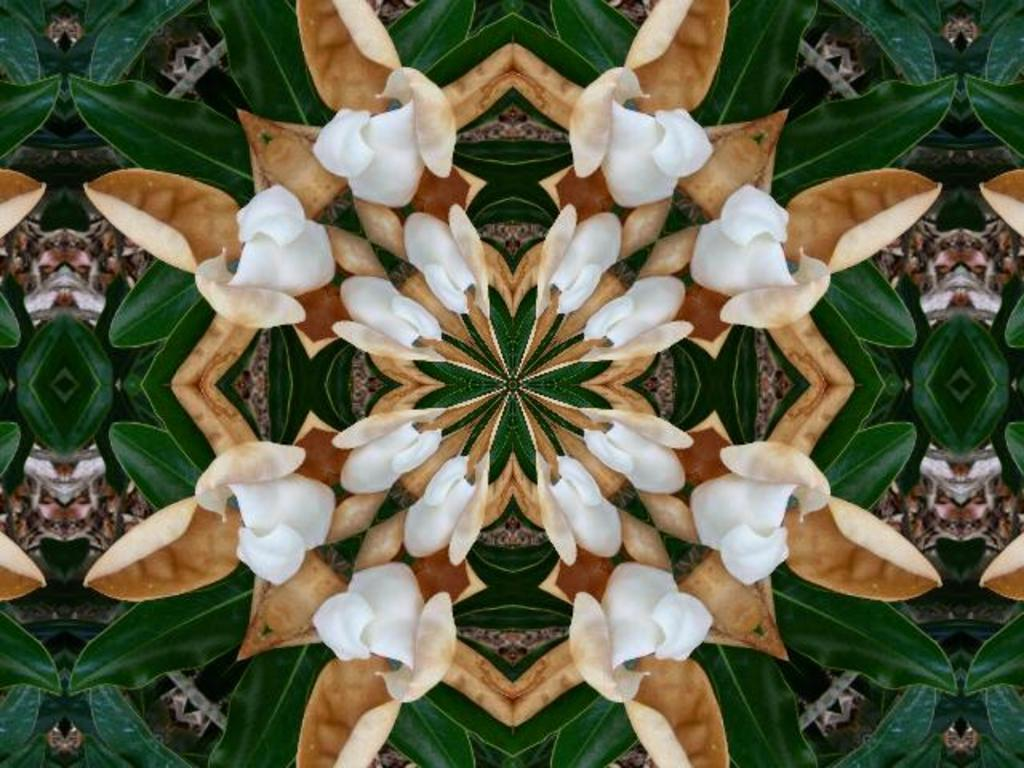What can be observed about the image's appearance? The image is edited. What type of vegetation is present in the image? There are plants with flowers in the image. What type of quill can be seen in the image? There is no quill present in the image. How many clocks are visible in the image? There are no clocks visible in the image. 